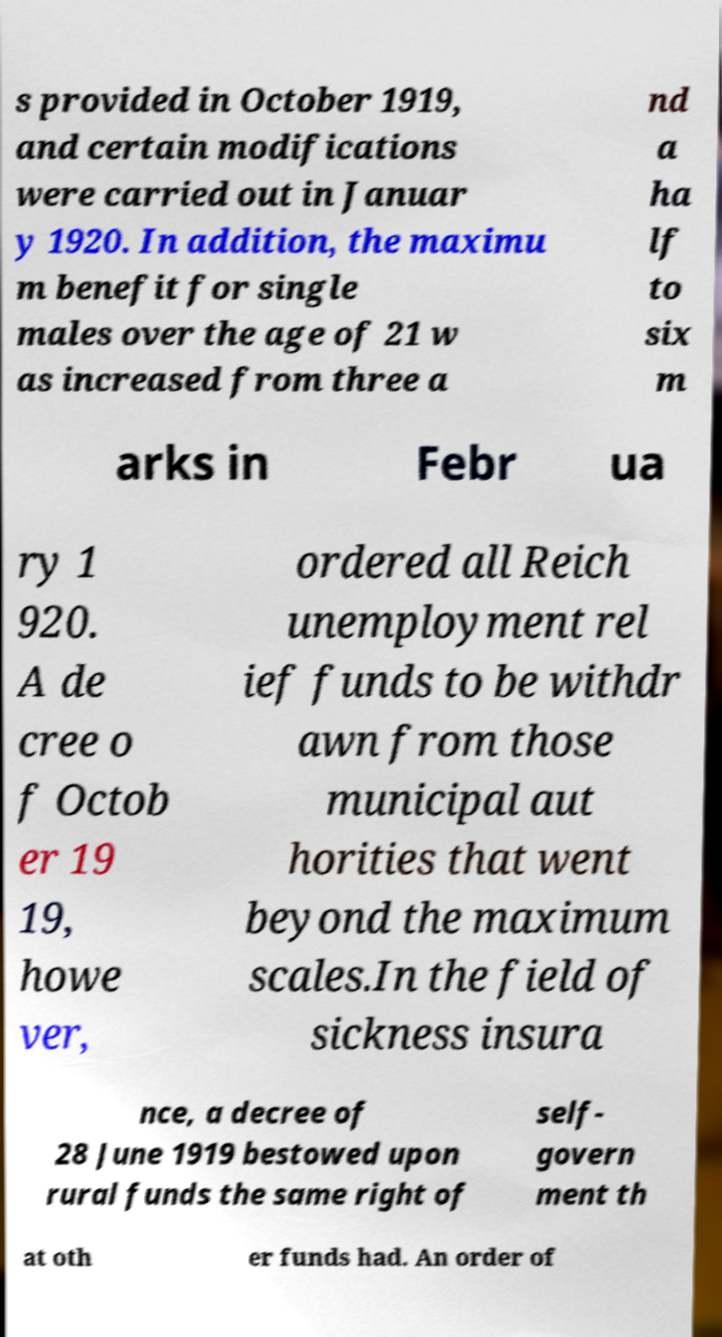What messages or text are displayed in this image? I need them in a readable, typed format. s provided in October 1919, and certain modifications were carried out in Januar y 1920. In addition, the maximu m benefit for single males over the age of 21 w as increased from three a nd a ha lf to six m arks in Febr ua ry 1 920. A de cree o f Octob er 19 19, howe ver, ordered all Reich unemployment rel ief funds to be withdr awn from those municipal aut horities that went beyond the maximum scales.In the field of sickness insura nce, a decree of 28 June 1919 bestowed upon rural funds the same right of self- govern ment th at oth er funds had. An order of 